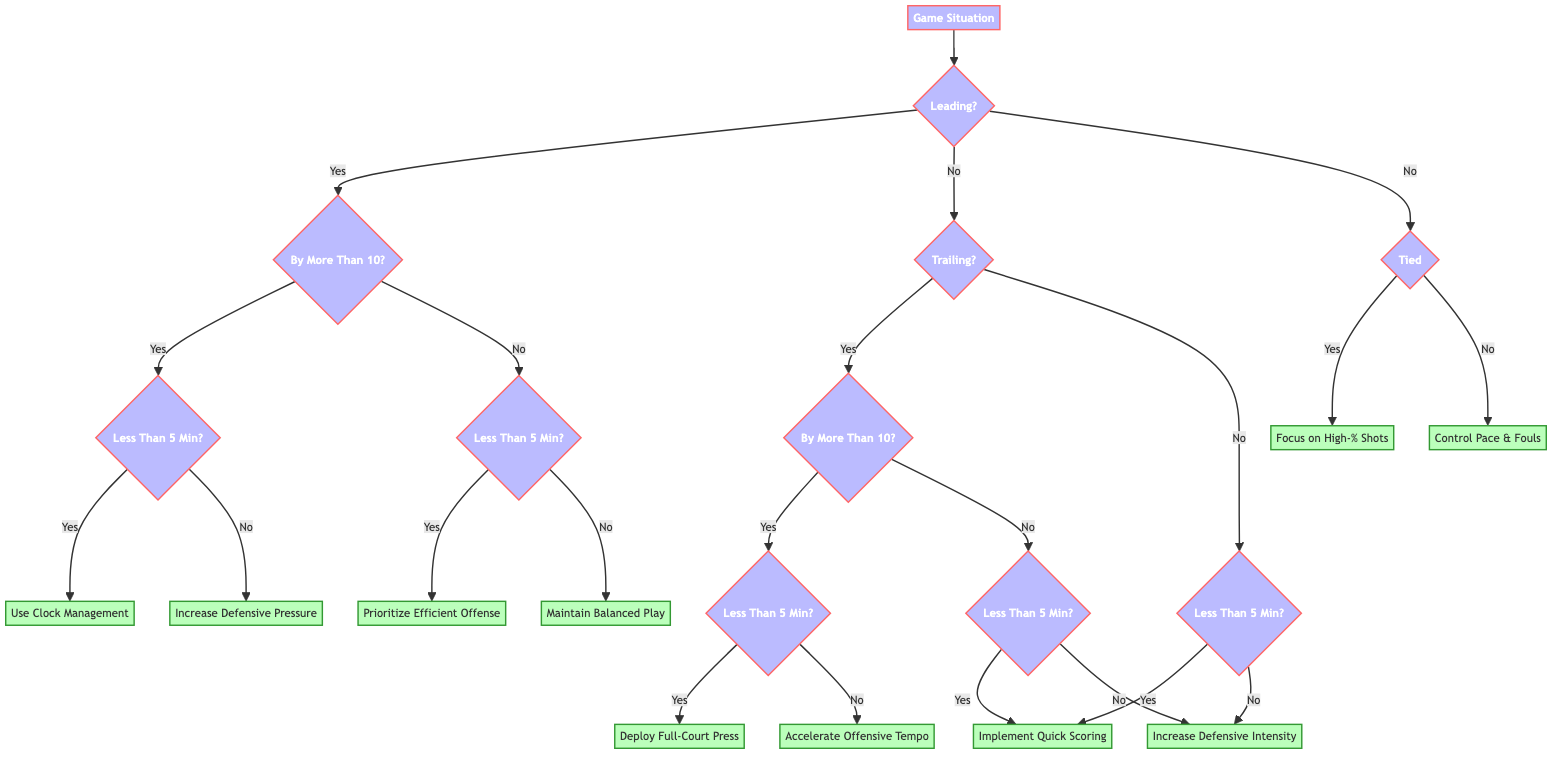What adjustment should be made if the team is leading by more than 10 points with more than 5 minutes remaining? In this case, the diagram indicates that the team should increase defensive pressure as a tactical adjustment. This is determined by following the path from "Leading" to "By More Than 10 Points" and then to "More Than 5 Minutes Remaining."
Answer: Increase Defensive Pressure What happens if the team is tied with less than 5 minutes remaining? According to the diagram, when the game is tied and there are less than 5 minutes left, the focus should be on high-percentage shots. This result comes directly from the "Tied" node to "Less Than 5 Minutes Remaining."
Answer: Focus on High-Percentage Shots How many total possible actions are listed in the diagram? To determine this, count the action nodes in the diagram. There are 7 distinct actions (Use Clock Management, Increase Defensive Pressure, Prioritize Efficient Offense, Maintain Balanced Play, Deploy Full-Court Press, Accelerate Offensive Tempo, Focus on High-Percentage Shots, Control Pace & Fouls, Implement Quick Scoring Plays, Increase Defensive Intensity). Thus, the total is 10 actions.
Answer: 10 What should the team implement if they are trailing by more than 10 points with less than 5 minutes remaining? The diagram shows that the appropriate action for this scenario is to deploy a full-court press. This can be derived from the "Trailing" section leading to "By More Than 10 Points" and then "Less Than 5 Minutes Remaining."
Answer: Deploy Full-Court Press What strategy should be employed if the team is trailing by less than 10 points with more than 5 minutes remaining? The action specified in this case is to increase defensive intensity, as shown in the diagram where the flow leads from "Trailing" to "By Less Than 10 Points" and then to "More Than 5 Minutes Remaining."
Answer: Increase Defensive Intensity How would the action change if the team is leading by less than 10 points with less than 5 minutes remaining? In this situation, the team should prioritize efficient offensive possessions, according to the diagram's path through "Leading" to "By Less Than 10 Points" and then "Less Than 5 Minutes Remaining."
Answer: Prioritize Efficient Offensive Possessions 